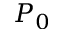Convert formula to latex. <formula><loc_0><loc_0><loc_500><loc_500>P _ { 0 }</formula> 